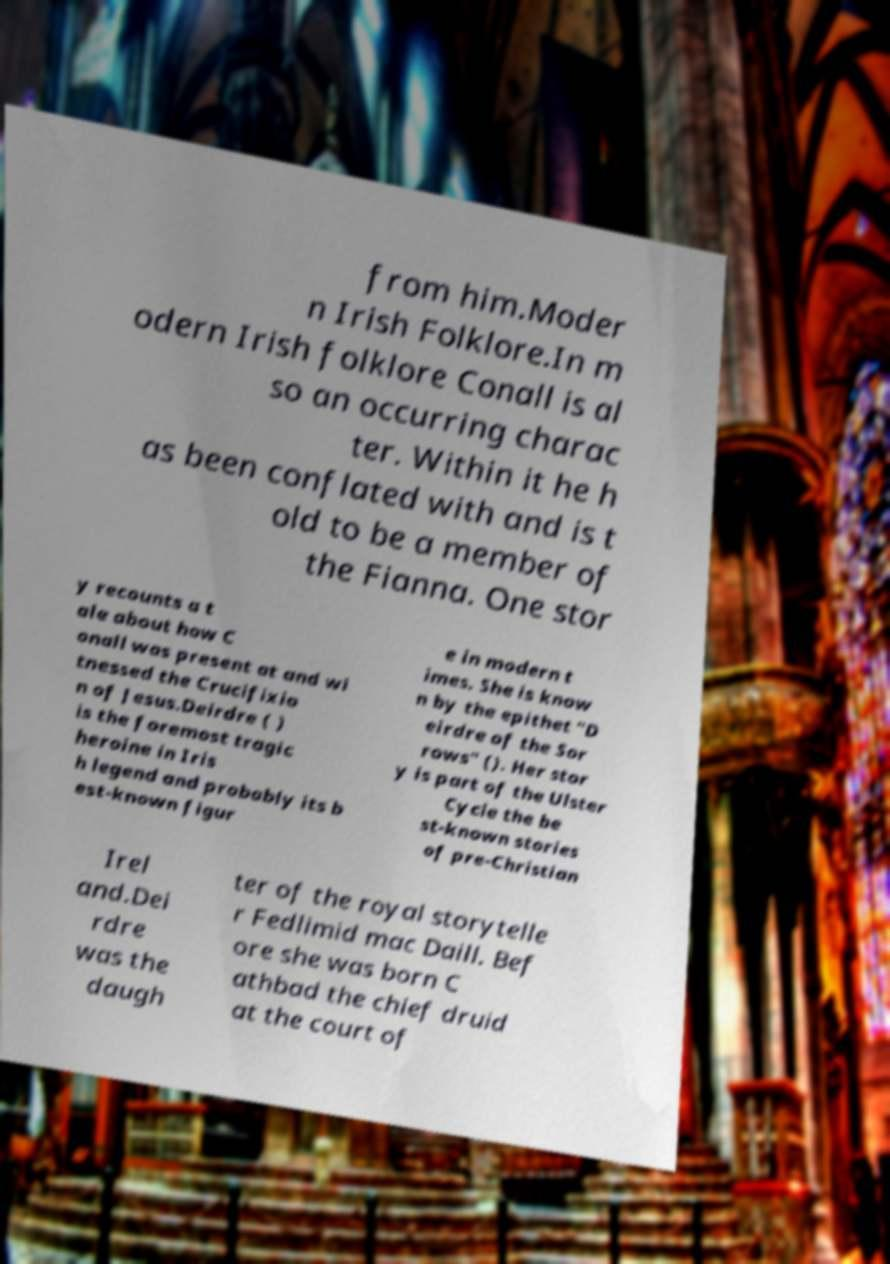I need the written content from this picture converted into text. Can you do that? from him.Moder n Irish Folklore.In m odern Irish folklore Conall is al so an occurring charac ter. Within it he h as been conflated with and is t old to be a member of the Fianna. One stor y recounts a t ale about how C onall was present at and wi tnessed the Crucifixio n of Jesus.Deirdre ( ) is the foremost tragic heroine in Iris h legend and probably its b est-known figur e in modern t imes. She is know n by the epithet "D eirdre of the Sor rows" (). Her stor y is part of the Ulster Cycle the be st-known stories of pre-Christian Irel and.Dei rdre was the daugh ter of the royal storytelle r Fedlimid mac Daill. Bef ore she was born C athbad the chief druid at the court of 